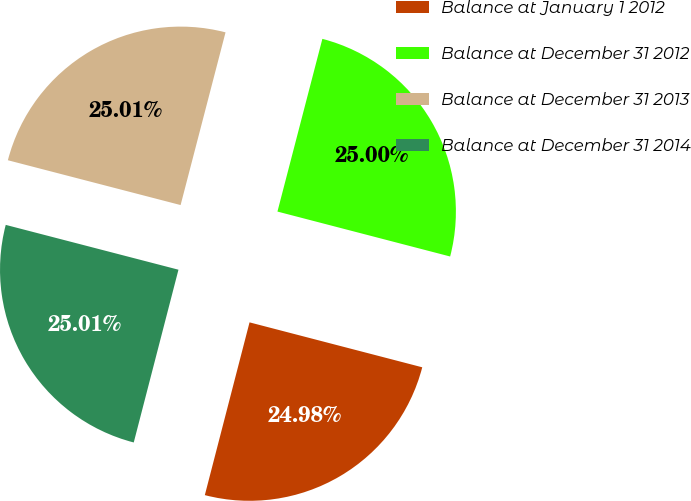Convert chart. <chart><loc_0><loc_0><loc_500><loc_500><pie_chart><fcel>Balance at January 1 2012<fcel>Balance at December 31 2012<fcel>Balance at December 31 2013<fcel>Balance at December 31 2014<nl><fcel>24.98%<fcel>25.0%<fcel>25.01%<fcel>25.01%<nl></chart> 